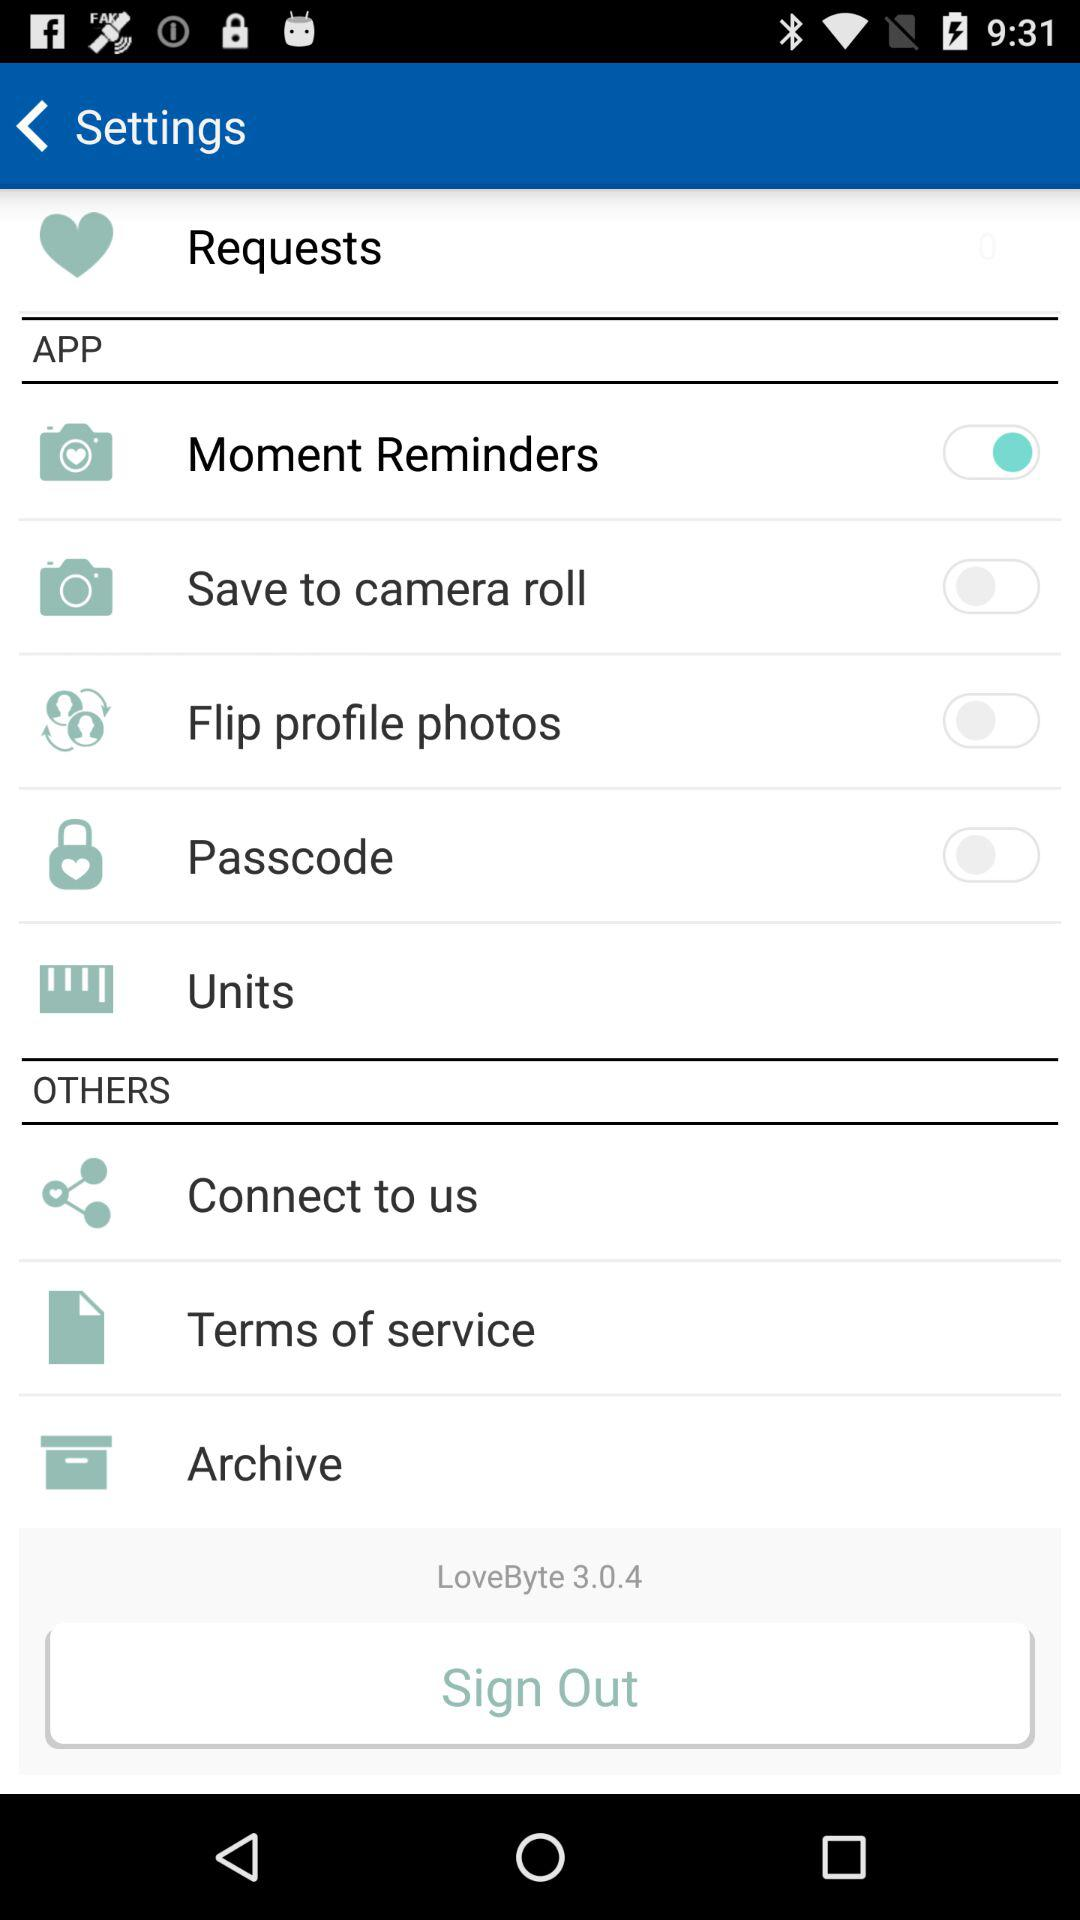What is the status of the "Passcode"? The status is "off". 